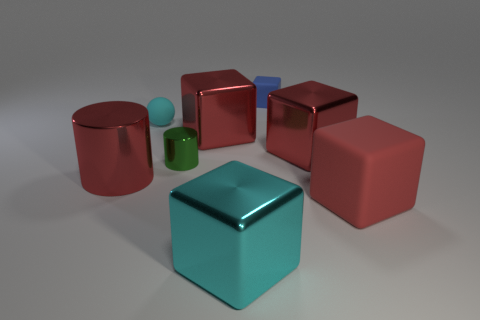Subtract all large red metal cubes. How many cubes are left? 3 Add 2 metallic blocks. How many objects exist? 10 Subtract all cyan blocks. How many blocks are left? 4 Subtract 1 cubes. How many cubes are left? 4 Subtract all purple cubes. Subtract all brown spheres. How many cubes are left? 5 Subtract all purple cubes. How many green balls are left? 0 Subtract all cyan blocks. Subtract all cyan spheres. How many objects are left? 6 Add 4 cylinders. How many cylinders are left? 6 Add 6 blue metallic objects. How many blue metallic objects exist? 6 Subtract 0 blue balls. How many objects are left? 8 